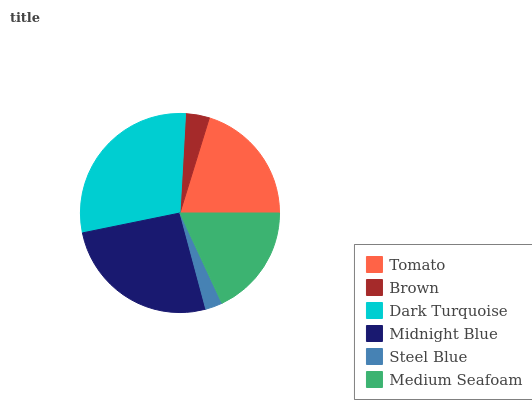Is Steel Blue the minimum?
Answer yes or no. Yes. Is Dark Turquoise the maximum?
Answer yes or no. Yes. Is Brown the minimum?
Answer yes or no. No. Is Brown the maximum?
Answer yes or no. No. Is Tomato greater than Brown?
Answer yes or no. Yes. Is Brown less than Tomato?
Answer yes or no. Yes. Is Brown greater than Tomato?
Answer yes or no. No. Is Tomato less than Brown?
Answer yes or no. No. Is Tomato the high median?
Answer yes or no. Yes. Is Medium Seafoam the low median?
Answer yes or no. Yes. Is Medium Seafoam the high median?
Answer yes or no. No. Is Tomato the low median?
Answer yes or no. No. 